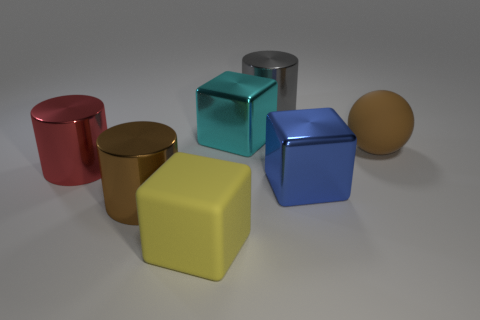The gray object that is the same shape as the large brown metal object is what size?
Keep it short and to the point. Large. Is the rubber cube the same color as the big sphere?
Offer a terse response. No. There is a shiny object that is left of the big gray shiny object and behind the big brown matte sphere; what color is it?
Give a very brief answer. Cyan. What number of things are big metallic cylinders behind the cyan metallic thing or brown cylinders?
Your answer should be compact. 2. There is another metallic object that is the same shape as the blue shiny object; what color is it?
Offer a very short reply. Cyan. There is a large brown rubber thing; is its shape the same as the large matte thing that is to the left of the large blue thing?
Offer a very short reply. No. How many objects are big things to the left of the brown rubber object or large brown things that are on the right side of the large gray metal cylinder?
Keep it short and to the point. 7. Are there fewer large blocks on the left side of the big blue cube than objects?
Keep it short and to the point. Yes. Does the big gray cylinder have the same material as the brown object that is behind the red metal cylinder?
Ensure brevity in your answer.  No. What material is the big gray thing?
Your answer should be very brief. Metal. 